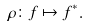Convert formula to latex. <formula><loc_0><loc_0><loc_500><loc_500>\rho \colon f \mapsto f ^ { \ast } .</formula> 